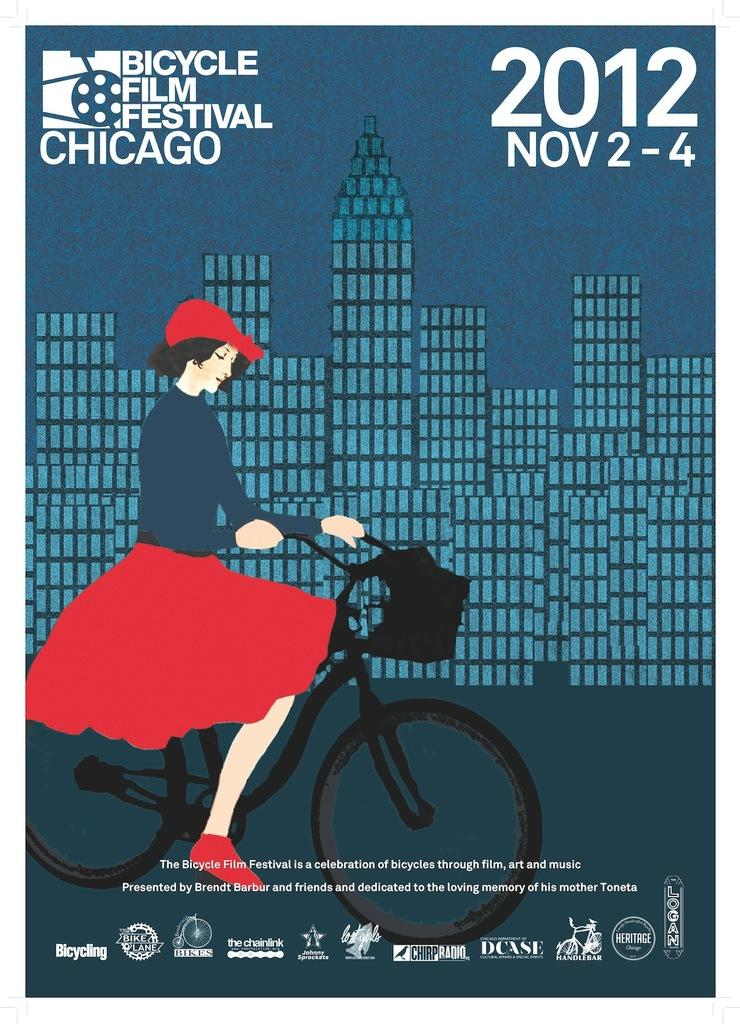What is the main subject of the image? There is an advertisement in the image. What activity is the girl in the image engaged in? The girl is on a cycle in the image. What type of structures can be seen in the image? There are buildings in the image. Where is text located in the image? There is text at the top and bottom of the image. What type of rabbit can be seen in the image? There is no rabbit present in the image. What religious symbols are visible in the image? There is no mention of religion or religious symbols in the image. 